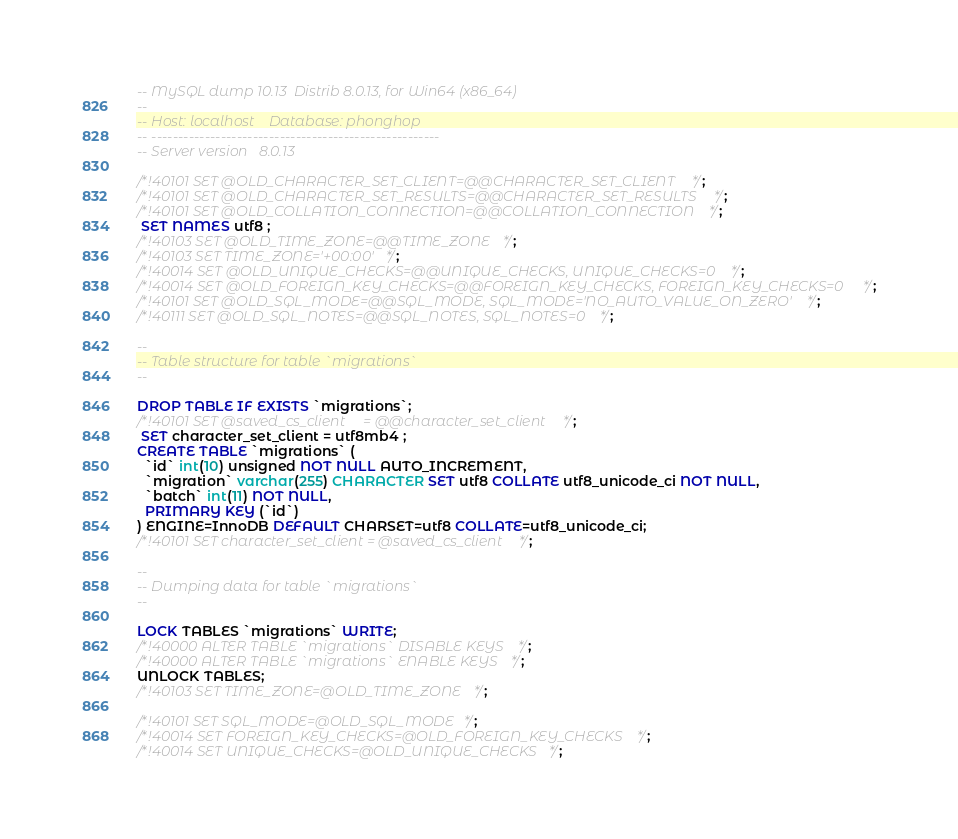Convert code to text. <code><loc_0><loc_0><loc_500><loc_500><_SQL_>-- MySQL dump 10.13  Distrib 8.0.13, for Win64 (x86_64)
--
-- Host: localhost    Database: phonghop
-- ------------------------------------------------------
-- Server version	8.0.13

/*!40101 SET @OLD_CHARACTER_SET_CLIENT=@@CHARACTER_SET_CLIENT */;
/*!40101 SET @OLD_CHARACTER_SET_RESULTS=@@CHARACTER_SET_RESULTS */;
/*!40101 SET @OLD_COLLATION_CONNECTION=@@COLLATION_CONNECTION */;
 SET NAMES utf8 ;
/*!40103 SET @OLD_TIME_ZONE=@@TIME_ZONE */;
/*!40103 SET TIME_ZONE='+00:00' */;
/*!40014 SET @OLD_UNIQUE_CHECKS=@@UNIQUE_CHECKS, UNIQUE_CHECKS=0 */;
/*!40014 SET @OLD_FOREIGN_KEY_CHECKS=@@FOREIGN_KEY_CHECKS, FOREIGN_KEY_CHECKS=0 */;
/*!40101 SET @OLD_SQL_MODE=@@SQL_MODE, SQL_MODE='NO_AUTO_VALUE_ON_ZERO' */;
/*!40111 SET @OLD_SQL_NOTES=@@SQL_NOTES, SQL_NOTES=0 */;

--
-- Table structure for table `migrations`
--

DROP TABLE IF EXISTS `migrations`;
/*!40101 SET @saved_cs_client     = @@character_set_client */;
 SET character_set_client = utf8mb4 ;
CREATE TABLE `migrations` (
  `id` int(10) unsigned NOT NULL AUTO_INCREMENT,
  `migration` varchar(255) CHARACTER SET utf8 COLLATE utf8_unicode_ci NOT NULL,
  `batch` int(11) NOT NULL,
  PRIMARY KEY (`id`)
) ENGINE=InnoDB DEFAULT CHARSET=utf8 COLLATE=utf8_unicode_ci;
/*!40101 SET character_set_client = @saved_cs_client */;

--
-- Dumping data for table `migrations`
--

LOCK TABLES `migrations` WRITE;
/*!40000 ALTER TABLE `migrations` DISABLE KEYS */;
/*!40000 ALTER TABLE `migrations` ENABLE KEYS */;
UNLOCK TABLES;
/*!40103 SET TIME_ZONE=@OLD_TIME_ZONE */;

/*!40101 SET SQL_MODE=@OLD_SQL_MODE */;
/*!40014 SET FOREIGN_KEY_CHECKS=@OLD_FOREIGN_KEY_CHECKS */;
/*!40014 SET UNIQUE_CHECKS=@OLD_UNIQUE_CHECKS */;</code> 